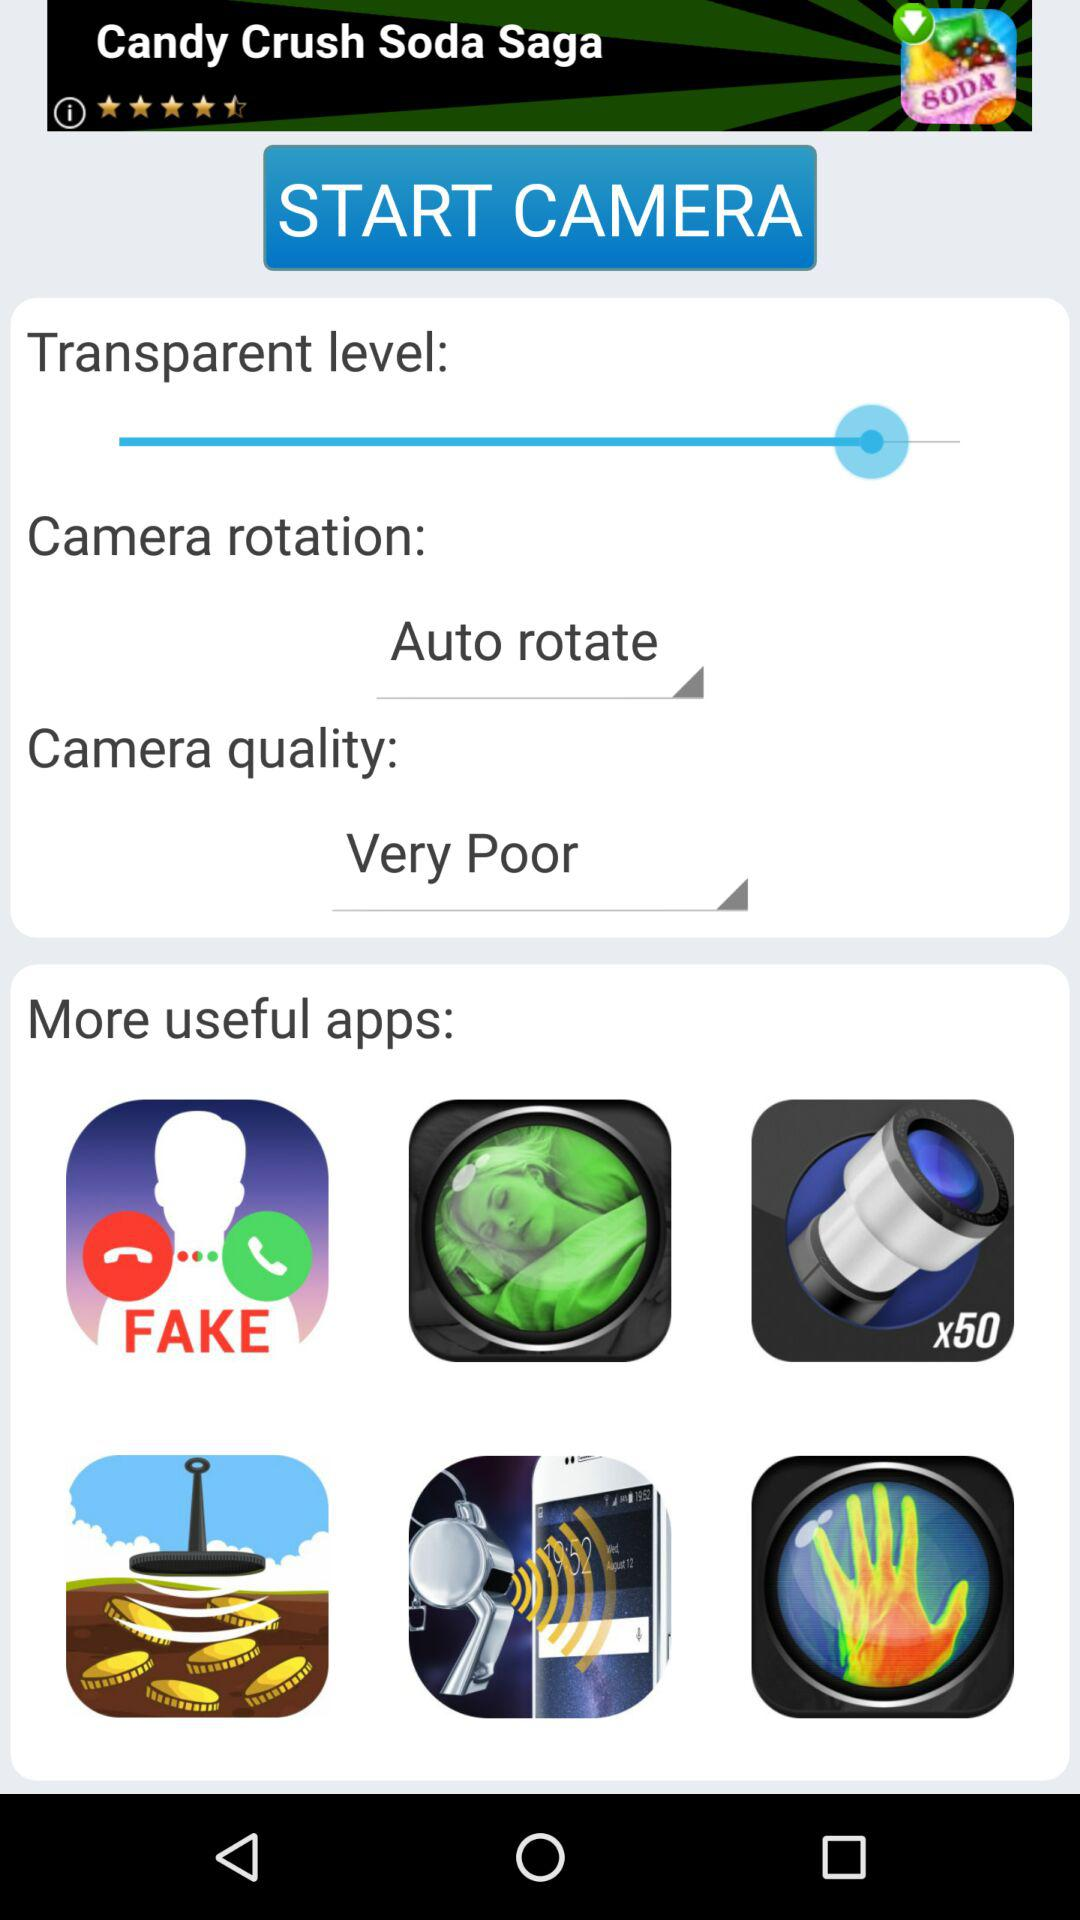What is the camera quality? The camera quality is "Very Poor". 